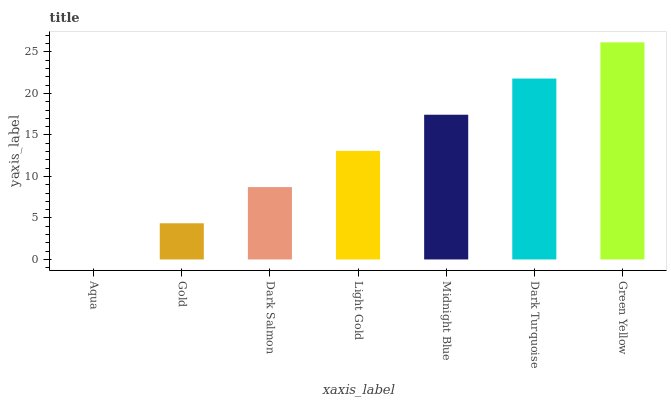Is Aqua the minimum?
Answer yes or no. Yes. Is Green Yellow the maximum?
Answer yes or no. Yes. Is Gold the minimum?
Answer yes or no. No. Is Gold the maximum?
Answer yes or no. No. Is Gold greater than Aqua?
Answer yes or no. Yes. Is Aqua less than Gold?
Answer yes or no. Yes. Is Aqua greater than Gold?
Answer yes or no. No. Is Gold less than Aqua?
Answer yes or no. No. Is Light Gold the high median?
Answer yes or no. Yes. Is Light Gold the low median?
Answer yes or no. Yes. Is Dark Salmon the high median?
Answer yes or no. No. Is Dark Salmon the low median?
Answer yes or no. No. 